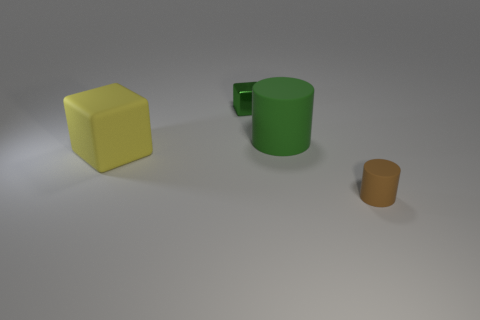Subtract all yellow cylinders. Subtract all purple spheres. How many cylinders are left? 2 Subtract all red cylinders. How many green blocks are left? 1 Add 4 large greens. How many small browns exist? 0 Subtract all tiny red matte balls. Subtract all small matte things. How many objects are left? 3 Add 4 brown matte objects. How many brown matte objects are left? 5 Add 1 tiny cyan matte balls. How many tiny cyan matte balls exist? 1 Add 3 tiny rubber cylinders. How many objects exist? 7 Subtract all brown cylinders. How many cylinders are left? 1 Subtract 0 brown blocks. How many objects are left? 4 Subtract 1 cylinders. How many cylinders are left? 1 